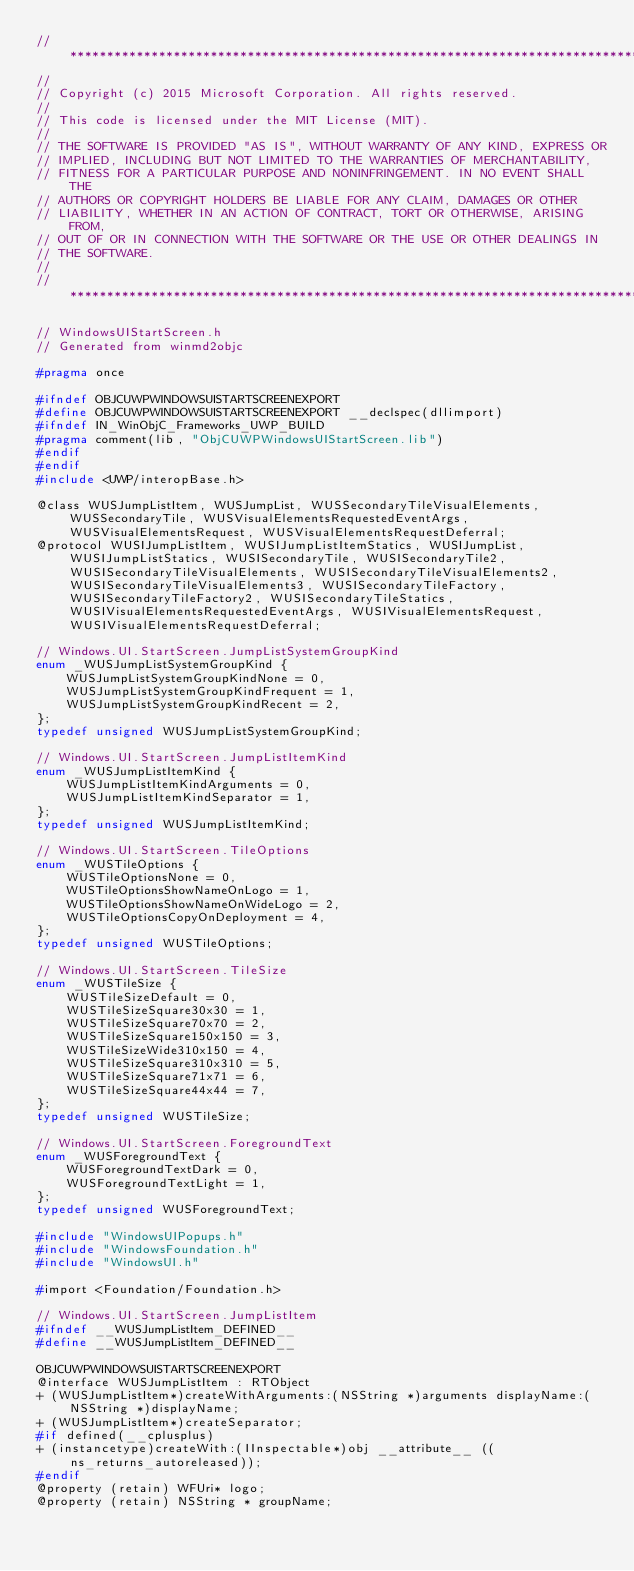Convert code to text. <code><loc_0><loc_0><loc_500><loc_500><_C_>//******************************************************************************
//
// Copyright (c) 2015 Microsoft Corporation. All rights reserved.
//
// This code is licensed under the MIT License (MIT).
//
// THE SOFTWARE IS PROVIDED "AS IS", WITHOUT WARRANTY OF ANY KIND, EXPRESS OR
// IMPLIED, INCLUDING BUT NOT LIMITED TO THE WARRANTIES OF MERCHANTABILITY,
// FITNESS FOR A PARTICULAR PURPOSE AND NONINFRINGEMENT. IN NO EVENT SHALL THE
// AUTHORS OR COPYRIGHT HOLDERS BE LIABLE FOR ANY CLAIM, DAMAGES OR OTHER
// LIABILITY, WHETHER IN AN ACTION OF CONTRACT, TORT OR OTHERWISE, ARISING FROM,
// OUT OF OR IN CONNECTION WITH THE SOFTWARE OR THE USE OR OTHER DEALINGS IN
// THE SOFTWARE.
//
//******************************************************************************

// WindowsUIStartScreen.h
// Generated from winmd2objc

#pragma once

#ifndef OBJCUWPWINDOWSUISTARTSCREENEXPORT
#define OBJCUWPWINDOWSUISTARTSCREENEXPORT __declspec(dllimport)
#ifndef IN_WinObjC_Frameworks_UWP_BUILD
#pragma comment(lib, "ObjCUWPWindowsUIStartScreen.lib")
#endif
#endif
#include <UWP/interopBase.h>

@class WUSJumpListItem, WUSJumpList, WUSSecondaryTileVisualElements, WUSSecondaryTile, WUSVisualElementsRequestedEventArgs, WUSVisualElementsRequest, WUSVisualElementsRequestDeferral;
@protocol WUSIJumpListItem, WUSIJumpListItemStatics, WUSIJumpList, WUSIJumpListStatics, WUSISecondaryTile, WUSISecondaryTile2, WUSISecondaryTileVisualElements, WUSISecondaryTileVisualElements2, WUSISecondaryTileVisualElements3, WUSISecondaryTileFactory, WUSISecondaryTileFactory2, WUSISecondaryTileStatics, WUSIVisualElementsRequestedEventArgs, WUSIVisualElementsRequest, WUSIVisualElementsRequestDeferral;

// Windows.UI.StartScreen.JumpListSystemGroupKind
enum _WUSJumpListSystemGroupKind {
    WUSJumpListSystemGroupKindNone = 0,
    WUSJumpListSystemGroupKindFrequent = 1,
    WUSJumpListSystemGroupKindRecent = 2,
};
typedef unsigned WUSJumpListSystemGroupKind;

// Windows.UI.StartScreen.JumpListItemKind
enum _WUSJumpListItemKind {
    WUSJumpListItemKindArguments = 0,
    WUSJumpListItemKindSeparator = 1,
};
typedef unsigned WUSJumpListItemKind;

// Windows.UI.StartScreen.TileOptions
enum _WUSTileOptions {
    WUSTileOptionsNone = 0,
    WUSTileOptionsShowNameOnLogo = 1,
    WUSTileOptionsShowNameOnWideLogo = 2,
    WUSTileOptionsCopyOnDeployment = 4,
};
typedef unsigned WUSTileOptions;

// Windows.UI.StartScreen.TileSize
enum _WUSTileSize {
    WUSTileSizeDefault = 0,
    WUSTileSizeSquare30x30 = 1,
    WUSTileSizeSquare70x70 = 2,
    WUSTileSizeSquare150x150 = 3,
    WUSTileSizeWide310x150 = 4,
    WUSTileSizeSquare310x310 = 5,
    WUSTileSizeSquare71x71 = 6,
    WUSTileSizeSquare44x44 = 7,
};
typedef unsigned WUSTileSize;

// Windows.UI.StartScreen.ForegroundText
enum _WUSForegroundText {
    WUSForegroundTextDark = 0,
    WUSForegroundTextLight = 1,
};
typedef unsigned WUSForegroundText;

#include "WindowsUIPopups.h"
#include "WindowsFoundation.h"
#include "WindowsUI.h"

#import <Foundation/Foundation.h>

// Windows.UI.StartScreen.JumpListItem
#ifndef __WUSJumpListItem_DEFINED__
#define __WUSJumpListItem_DEFINED__

OBJCUWPWINDOWSUISTARTSCREENEXPORT
@interface WUSJumpListItem : RTObject
+ (WUSJumpListItem*)createWithArguments:(NSString *)arguments displayName:(NSString *)displayName;
+ (WUSJumpListItem*)createSeparator;
#if defined(__cplusplus)
+ (instancetype)createWith:(IInspectable*)obj __attribute__ ((ns_returns_autoreleased));
#endif
@property (retain) WFUri* logo;
@property (retain) NSString * groupName;</code> 